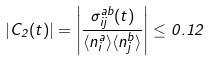Convert formula to latex. <formula><loc_0><loc_0><loc_500><loc_500>| C _ { 2 } ( t ) | = \left | \frac { \sigma _ { i j } ^ { a b } ( t ) } { \langle n _ { i } ^ { a } \rangle \langle n _ { j } ^ { b } \rangle } \right | \leq 0 . 1 2</formula> 